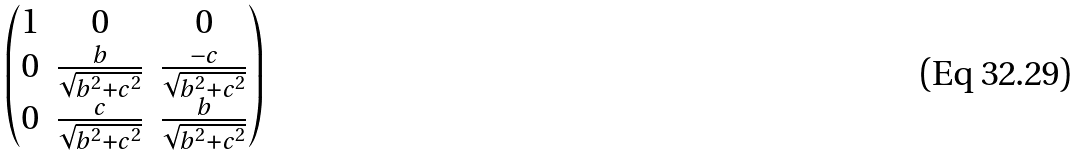Convert formula to latex. <formula><loc_0><loc_0><loc_500><loc_500>\begin{pmatrix} 1 & 0 & 0 \\ 0 & \frac { b } { \sqrt { b ^ { 2 } + c ^ { 2 } } } & \frac { - c } { \sqrt { b ^ { 2 } + c ^ { 2 } } } \\ 0 & \frac { c } { \sqrt { b ^ { 2 } + c ^ { 2 } } } & \frac { b } { \sqrt { b ^ { 2 } + c ^ { 2 } } } \\ \end{pmatrix}</formula> 